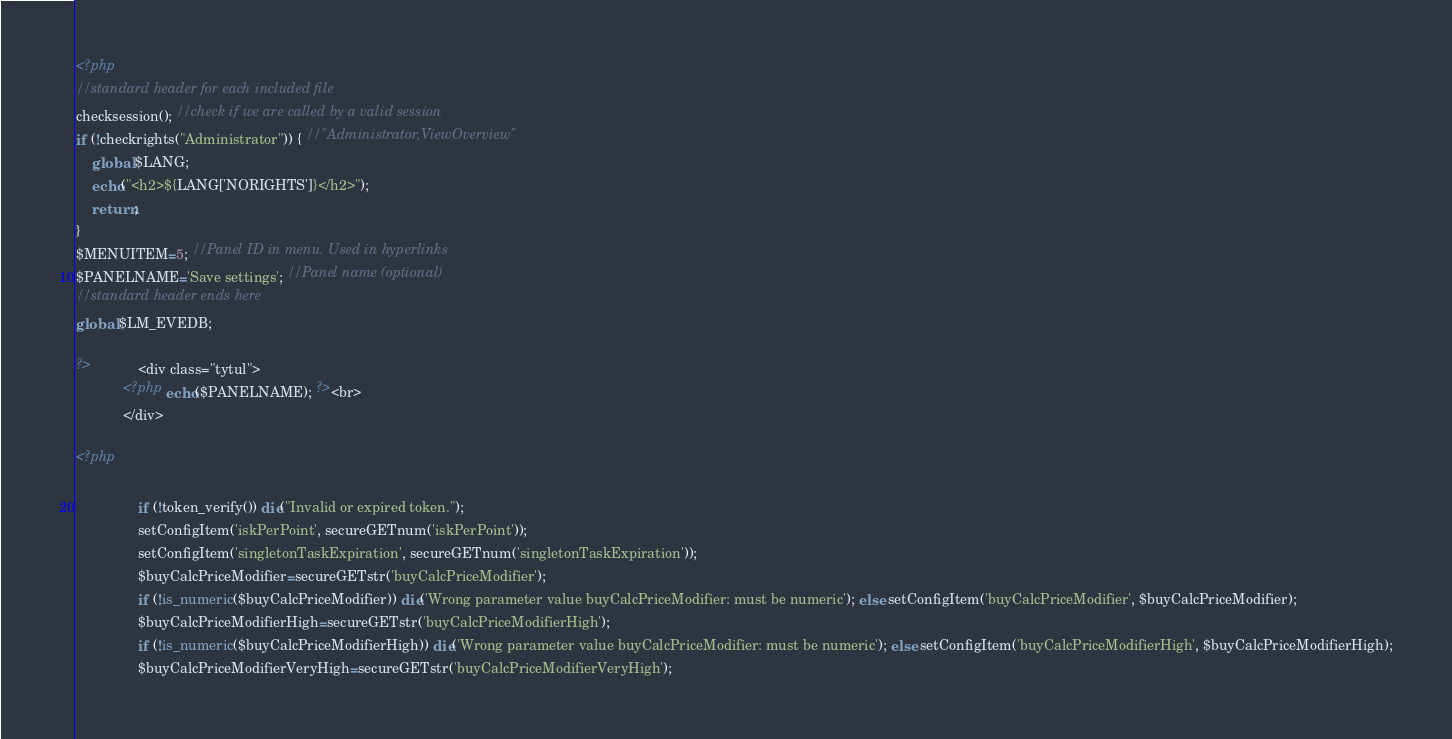Convert code to text. <code><loc_0><loc_0><loc_500><loc_500><_PHP_><?php
//standard header for each included file
checksession(); //check if we are called by a valid session
if (!checkrights("Administrator")) { //"Administrator,ViewOverview"
	global $LANG;
	echo("<h2>${LANG['NORIGHTS']}</h2>");
	return;
}
$MENUITEM=5; //Panel ID in menu. Used in hyperlinks
$PANELNAME='Save settings'; //Panel name (optional)
//standard header ends here
global $LM_EVEDB;

?>		    <div class="tytul">
			<?php echo($PANELNAME); ?><br>
		    </div>
		    
<?php

                if (!token_verify()) die("Invalid or expired token.");
                setConfigItem('iskPerPoint', secureGETnum('iskPerPoint'));
                setConfigItem('singletonTaskExpiration', secureGETnum('singletonTaskExpiration'));
                $buyCalcPriceModifier=secureGETstr('buyCalcPriceModifier');
                if (!is_numeric($buyCalcPriceModifier)) die('Wrong parameter value buyCalcPriceModifier: must be numeric'); else setConfigItem('buyCalcPriceModifier', $buyCalcPriceModifier);
                $buyCalcPriceModifierHigh=secureGETstr('buyCalcPriceModifierHigh');
                if (!is_numeric($buyCalcPriceModifierHigh)) die('Wrong parameter value buyCalcPriceModifier: must be numeric'); else setConfigItem('buyCalcPriceModifierHigh', $buyCalcPriceModifierHigh);
                $buyCalcPriceModifierVeryHigh=secureGETstr('buyCalcPriceModifierVeryHigh');</code> 